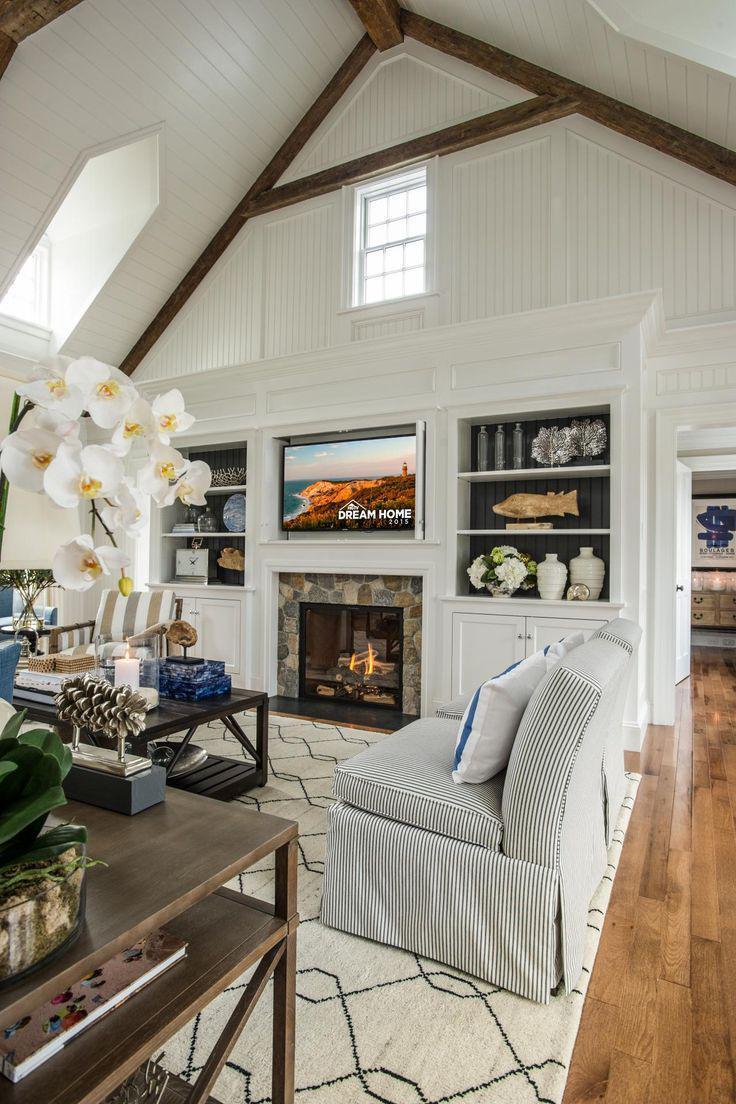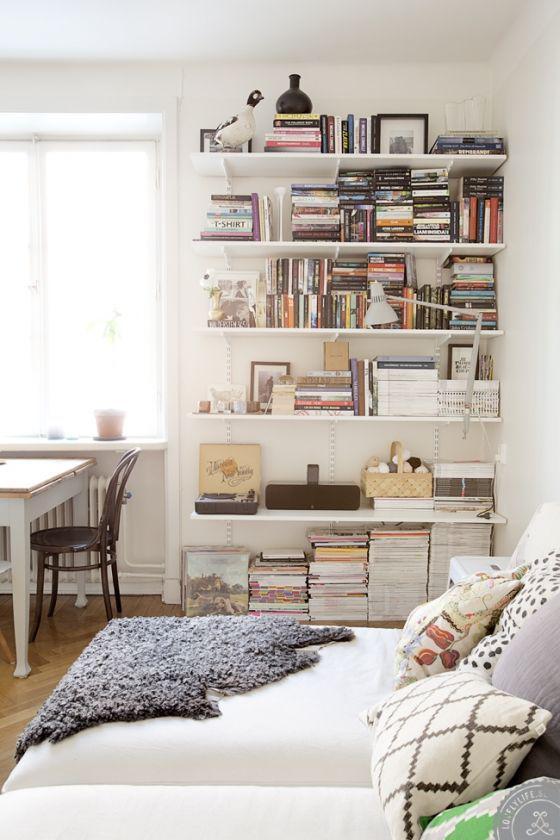The first image is the image on the left, the second image is the image on the right. Considering the images on both sides, is "In one image, a large white shelving unit has solid panel doors at the bottom, open shelves at the top, and a television in the center position." valid? Answer yes or no. Yes. 